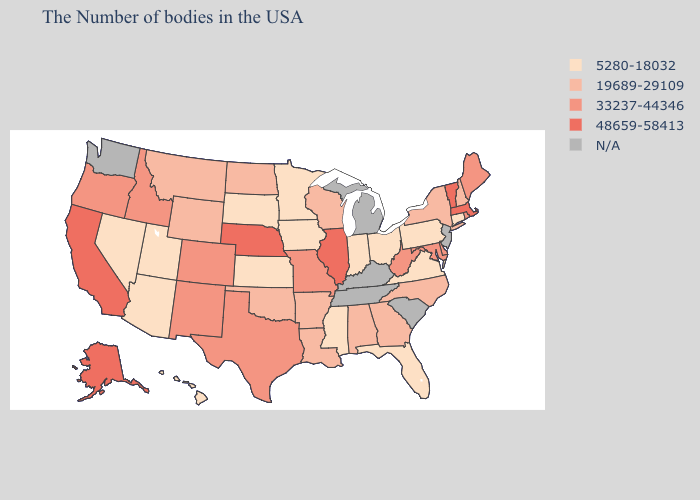What is the lowest value in states that border Louisiana?
Keep it brief. 5280-18032. What is the highest value in the South ?
Answer briefly. 33237-44346. Among the states that border Georgia , which have the lowest value?
Write a very short answer. Florida. Name the states that have a value in the range 19689-29109?
Concise answer only. New Hampshire, New York, North Carolina, Georgia, Alabama, Wisconsin, Louisiana, Arkansas, Oklahoma, North Dakota, Wyoming, Montana. Is the legend a continuous bar?
Answer briefly. No. What is the highest value in states that border Minnesota?
Be succinct. 19689-29109. What is the value of Colorado?
Quick response, please. 33237-44346. What is the highest value in the USA?
Quick response, please. 48659-58413. Which states have the lowest value in the Northeast?
Keep it brief. Connecticut, Pennsylvania. Name the states that have a value in the range 48659-58413?
Be succinct. Massachusetts, Vermont, Illinois, Nebraska, California, Alaska. Name the states that have a value in the range 5280-18032?
Keep it brief. Connecticut, Pennsylvania, Virginia, Ohio, Florida, Indiana, Mississippi, Minnesota, Iowa, Kansas, South Dakota, Utah, Arizona, Nevada, Hawaii. Among the states that border Maine , which have the highest value?
Quick response, please. New Hampshire. 